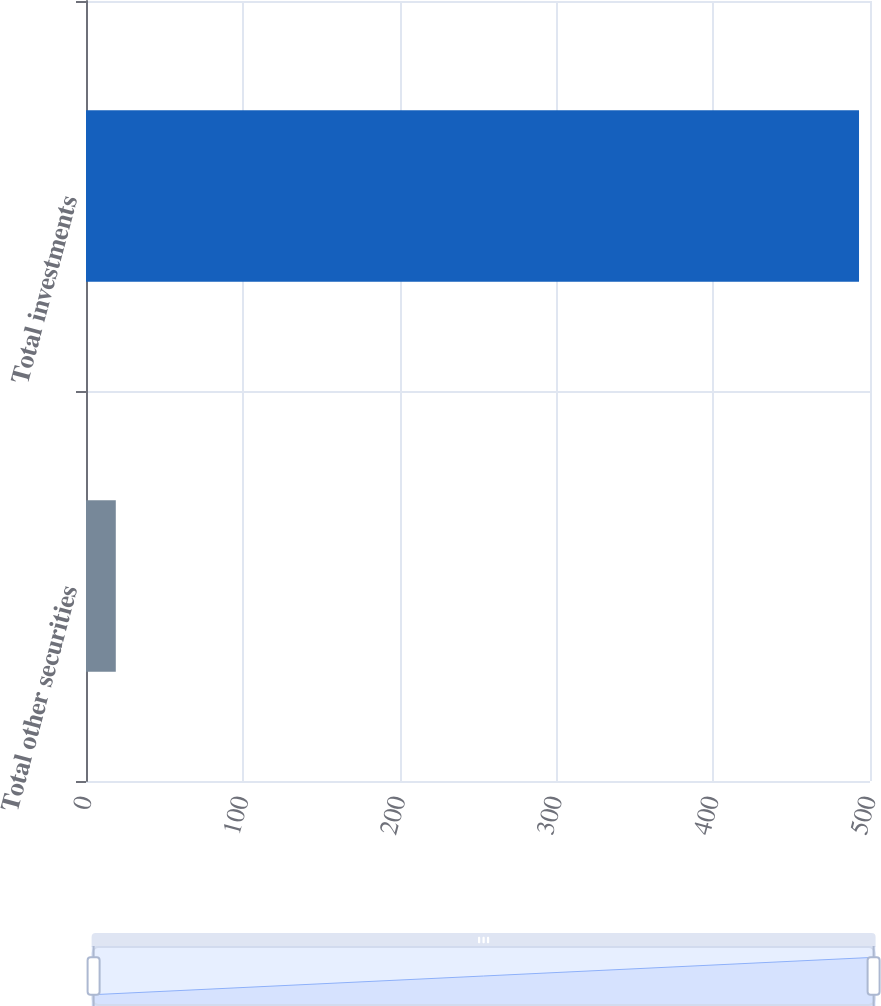Convert chart. <chart><loc_0><loc_0><loc_500><loc_500><bar_chart><fcel>Total other securities<fcel>Total investments<nl><fcel>19<fcel>493<nl></chart> 